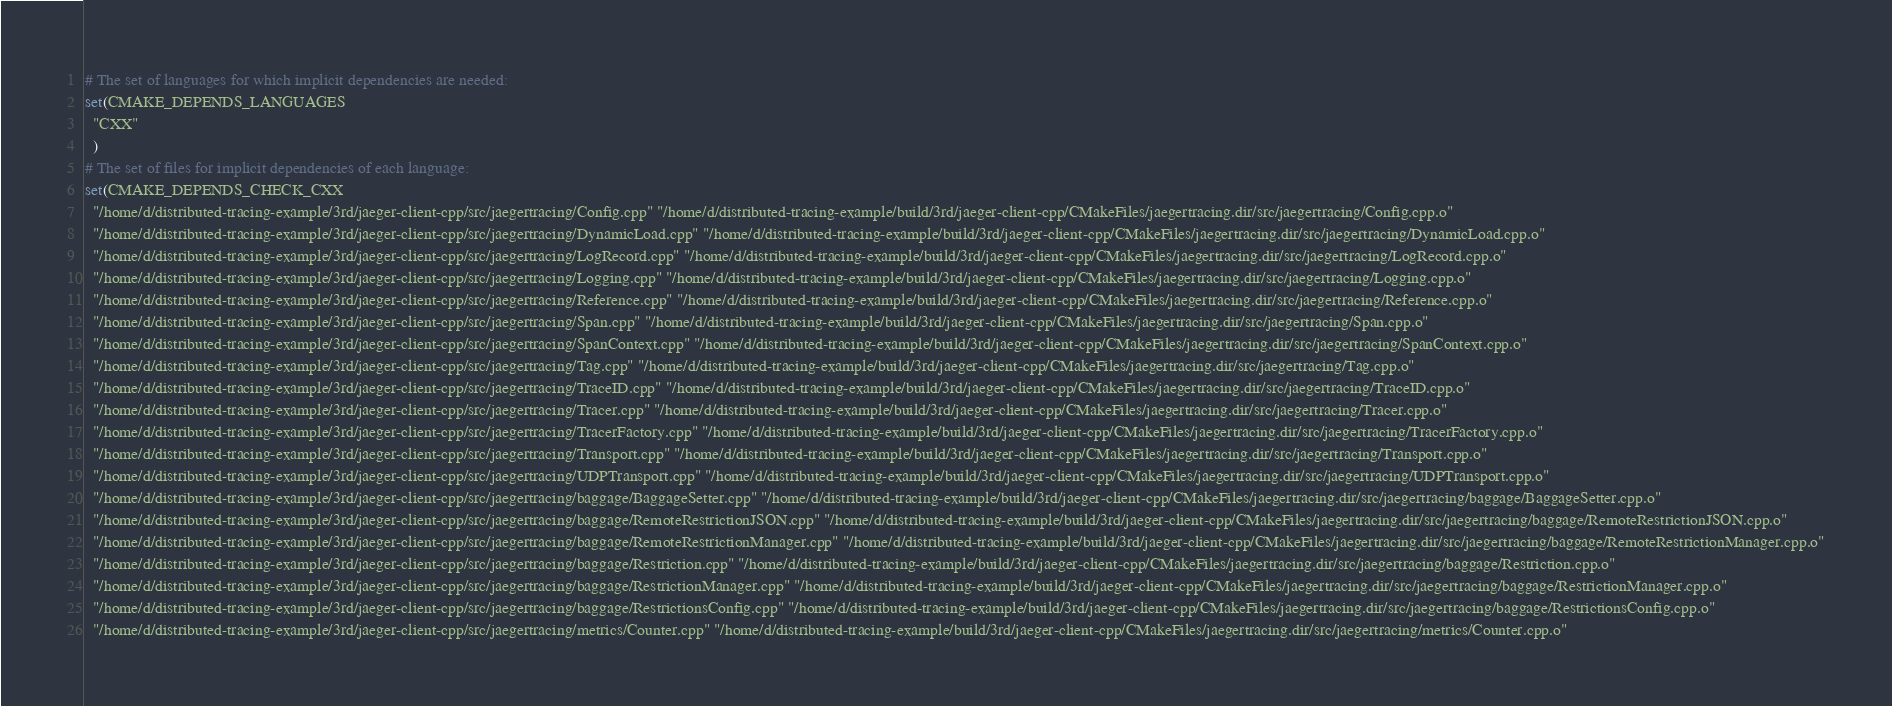<code> <loc_0><loc_0><loc_500><loc_500><_CMake_># The set of languages for which implicit dependencies are needed:
set(CMAKE_DEPENDS_LANGUAGES
  "CXX"
  )
# The set of files for implicit dependencies of each language:
set(CMAKE_DEPENDS_CHECK_CXX
  "/home/d/distributed-tracing-example/3rd/jaeger-client-cpp/src/jaegertracing/Config.cpp" "/home/d/distributed-tracing-example/build/3rd/jaeger-client-cpp/CMakeFiles/jaegertracing.dir/src/jaegertracing/Config.cpp.o"
  "/home/d/distributed-tracing-example/3rd/jaeger-client-cpp/src/jaegertracing/DynamicLoad.cpp" "/home/d/distributed-tracing-example/build/3rd/jaeger-client-cpp/CMakeFiles/jaegertracing.dir/src/jaegertracing/DynamicLoad.cpp.o"
  "/home/d/distributed-tracing-example/3rd/jaeger-client-cpp/src/jaegertracing/LogRecord.cpp" "/home/d/distributed-tracing-example/build/3rd/jaeger-client-cpp/CMakeFiles/jaegertracing.dir/src/jaegertracing/LogRecord.cpp.o"
  "/home/d/distributed-tracing-example/3rd/jaeger-client-cpp/src/jaegertracing/Logging.cpp" "/home/d/distributed-tracing-example/build/3rd/jaeger-client-cpp/CMakeFiles/jaegertracing.dir/src/jaegertracing/Logging.cpp.o"
  "/home/d/distributed-tracing-example/3rd/jaeger-client-cpp/src/jaegertracing/Reference.cpp" "/home/d/distributed-tracing-example/build/3rd/jaeger-client-cpp/CMakeFiles/jaegertracing.dir/src/jaegertracing/Reference.cpp.o"
  "/home/d/distributed-tracing-example/3rd/jaeger-client-cpp/src/jaegertracing/Span.cpp" "/home/d/distributed-tracing-example/build/3rd/jaeger-client-cpp/CMakeFiles/jaegertracing.dir/src/jaegertracing/Span.cpp.o"
  "/home/d/distributed-tracing-example/3rd/jaeger-client-cpp/src/jaegertracing/SpanContext.cpp" "/home/d/distributed-tracing-example/build/3rd/jaeger-client-cpp/CMakeFiles/jaegertracing.dir/src/jaegertracing/SpanContext.cpp.o"
  "/home/d/distributed-tracing-example/3rd/jaeger-client-cpp/src/jaegertracing/Tag.cpp" "/home/d/distributed-tracing-example/build/3rd/jaeger-client-cpp/CMakeFiles/jaegertracing.dir/src/jaegertracing/Tag.cpp.o"
  "/home/d/distributed-tracing-example/3rd/jaeger-client-cpp/src/jaegertracing/TraceID.cpp" "/home/d/distributed-tracing-example/build/3rd/jaeger-client-cpp/CMakeFiles/jaegertracing.dir/src/jaegertracing/TraceID.cpp.o"
  "/home/d/distributed-tracing-example/3rd/jaeger-client-cpp/src/jaegertracing/Tracer.cpp" "/home/d/distributed-tracing-example/build/3rd/jaeger-client-cpp/CMakeFiles/jaegertracing.dir/src/jaegertracing/Tracer.cpp.o"
  "/home/d/distributed-tracing-example/3rd/jaeger-client-cpp/src/jaegertracing/TracerFactory.cpp" "/home/d/distributed-tracing-example/build/3rd/jaeger-client-cpp/CMakeFiles/jaegertracing.dir/src/jaegertracing/TracerFactory.cpp.o"
  "/home/d/distributed-tracing-example/3rd/jaeger-client-cpp/src/jaegertracing/Transport.cpp" "/home/d/distributed-tracing-example/build/3rd/jaeger-client-cpp/CMakeFiles/jaegertracing.dir/src/jaegertracing/Transport.cpp.o"
  "/home/d/distributed-tracing-example/3rd/jaeger-client-cpp/src/jaegertracing/UDPTransport.cpp" "/home/d/distributed-tracing-example/build/3rd/jaeger-client-cpp/CMakeFiles/jaegertracing.dir/src/jaegertracing/UDPTransport.cpp.o"
  "/home/d/distributed-tracing-example/3rd/jaeger-client-cpp/src/jaegertracing/baggage/BaggageSetter.cpp" "/home/d/distributed-tracing-example/build/3rd/jaeger-client-cpp/CMakeFiles/jaegertracing.dir/src/jaegertracing/baggage/BaggageSetter.cpp.o"
  "/home/d/distributed-tracing-example/3rd/jaeger-client-cpp/src/jaegertracing/baggage/RemoteRestrictionJSON.cpp" "/home/d/distributed-tracing-example/build/3rd/jaeger-client-cpp/CMakeFiles/jaegertracing.dir/src/jaegertracing/baggage/RemoteRestrictionJSON.cpp.o"
  "/home/d/distributed-tracing-example/3rd/jaeger-client-cpp/src/jaegertracing/baggage/RemoteRestrictionManager.cpp" "/home/d/distributed-tracing-example/build/3rd/jaeger-client-cpp/CMakeFiles/jaegertracing.dir/src/jaegertracing/baggage/RemoteRestrictionManager.cpp.o"
  "/home/d/distributed-tracing-example/3rd/jaeger-client-cpp/src/jaegertracing/baggage/Restriction.cpp" "/home/d/distributed-tracing-example/build/3rd/jaeger-client-cpp/CMakeFiles/jaegertracing.dir/src/jaegertracing/baggage/Restriction.cpp.o"
  "/home/d/distributed-tracing-example/3rd/jaeger-client-cpp/src/jaegertracing/baggage/RestrictionManager.cpp" "/home/d/distributed-tracing-example/build/3rd/jaeger-client-cpp/CMakeFiles/jaegertracing.dir/src/jaegertracing/baggage/RestrictionManager.cpp.o"
  "/home/d/distributed-tracing-example/3rd/jaeger-client-cpp/src/jaegertracing/baggage/RestrictionsConfig.cpp" "/home/d/distributed-tracing-example/build/3rd/jaeger-client-cpp/CMakeFiles/jaegertracing.dir/src/jaegertracing/baggage/RestrictionsConfig.cpp.o"
  "/home/d/distributed-tracing-example/3rd/jaeger-client-cpp/src/jaegertracing/metrics/Counter.cpp" "/home/d/distributed-tracing-example/build/3rd/jaeger-client-cpp/CMakeFiles/jaegertracing.dir/src/jaegertracing/metrics/Counter.cpp.o"</code> 